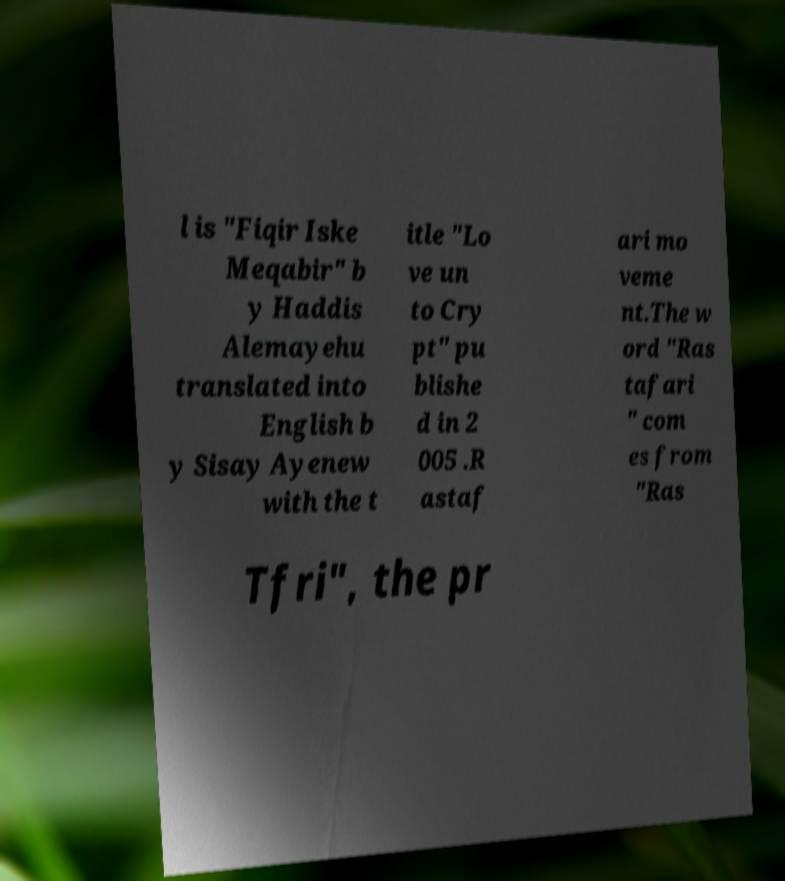Please read and relay the text visible in this image. What does it say? l is "Fiqir Iske Meqabir" b y Haddis Alemayehu translated into English b y Sisay Ayenew with the t itle "Lo ve un to Cry pt" pu blishe d in 2 005 .R astaf ari mo veme nt.The w ord "Ras tafari " com es from "Ras Tfri", the pr 